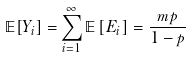<formula> <loc_0><loc_0><loc_500><loc_500>\mathbb { E } [ Y _ { i } ] = & \sum _ { i = 1 } ^ { \infty } \mathbb { E } \left [ E _ { i } \right ] = \frac { m p } { 1 - p }</formula> 